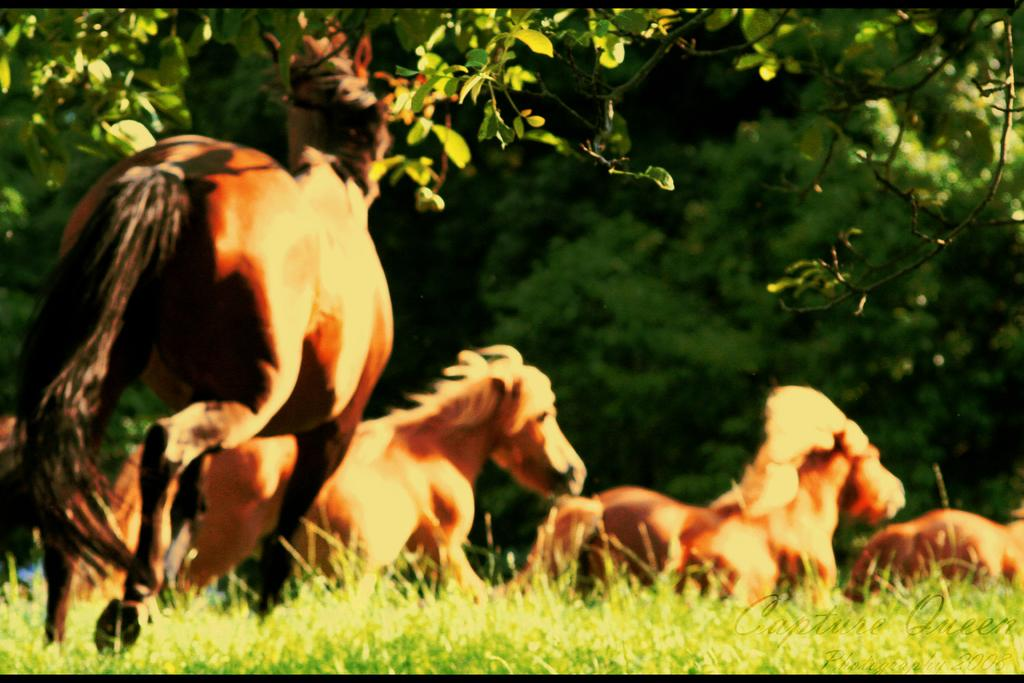What animals can be seen in the image? There are horses in the image. What are the horses doing in the image? The horses are running on the surface of the grass. What can be seen in the background of the image? There are trees visible in the background of the image. Where is the oven located in the image? There is no oven present in the image. What type of brush can be seen in the hands of the horses? Horses do not have hands, and there are no brushes visible in the image. 